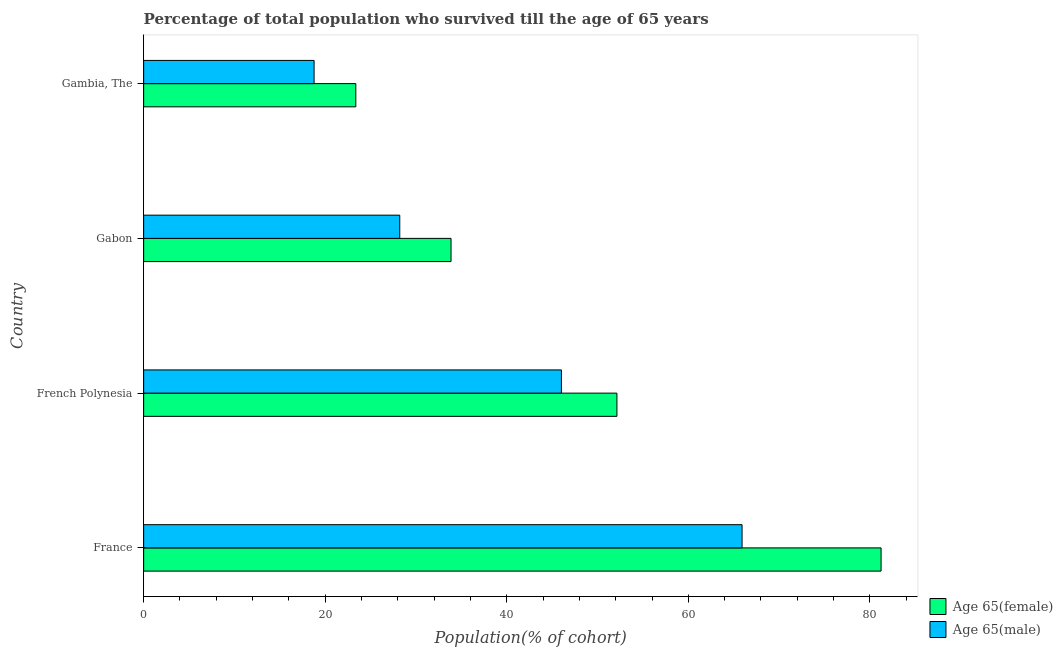How many different coloured bars are there?
Your response must be concise. 2. How many groups of bars are there?
Offer a very short reply. 4. How many bars are there on the 4th tick from the bottom?
Your answer should be compact. 2. What is the percentage of female population who survived till age of 65 in France?
Your answer should be compact. 81.23. Across all countries, what is the maximum percentage of male population who survived till age of 65?
Offer a very short reply. 65.92. Across all countries, what is the minimum percentage of female population who survived till age of 65?
Your answer should be compact. 23.37. In which country was the percentage of male population who survived till age of 65 minimum?
Provide a succinct answer. Gambia, The. What is the total percentage of female population who survived till age of 65 in the graph?
Provide a short and direct response. 190.6. What is the difference between the percentage of male population who survived till age of 65 in French Polynesia and that in Gambia, The?
Provide a short and direct response. 27.25. What is the difference between the percentage of male population who survived till age of 65 in Gambia, The and the percentage of female population who survived till age of 65 in France?
Offer a terse response. -62.46. What is the average percentage of male population who survived till age of 65 per country?
Ensure brevity in your answer.  39.73. What is the difference between the percentage of female population who survived till age of 65 and percentage of male population who survived till age of 65 in Gabon?
Your response must be concise. 5.65. In how many countries, is the percentage of female population who survived till age of 65 greater than 80 %?
Offer a terse response. 1. What is the ratio of the percentage of male population who survived till age of 65 in Gabon to that in Gambia, The?
Ensure brevity in your answer.  1.5. Is the percentage of female population who survived till age of 65 in France less than that in French Polynesia?
Offer a very short reply. No. What is the difference between the highest and the second highest percentage of male population who survived till age of 65?
Give a very brief answer. 19.9. What is the difference between the highest and the lowest percentage of female population who survived till age of 65?
Offer a terse response. 57.86. Is the sum of the percentage of female population who survived till age of 65 in France and Gambia, The greater than the maximum percentage of male population who survived till age of 65 across all countries?
Provide a succinct answer. Yes. What does the 2nd bar from the top in Gambia, The represents?
Give a very brief answer. Age 65(female). What does the 2nd bar from the bottom in French Polynesia represents?
Ensure brevity in your answer.  Age 65(male). How many bars are there?
Ensure brevity in your answer.  8. How many countries are there in the graph?
Offer a terse response. 4. Are the values on the major ticks of X-axis written in scientific E-notation?
Offer a terse response. No. Does the graph contain grids?
Your answer should be compact. No. How are the legend labels stacked?
Your answer should be very brief. Vertical. What is the title of the graph?
Your response must be concise. Percentage of total population who survived till the age of 65 years. What is the label or title of the X-axis?
Your answer should be very brief. Population(% of cohort). What is the Population(% of cohort) of Age 65(female) in France?
Keep it short and to the point. 81.23. What is the Population(% of cohort) in Age 65(male) in France?
Offer a very short reply. 65.92. What is the Population(% of cohort) in Age 65(female) in French Polynesia?
Provide a short and direct response. 52.14. What is the Population(% of cohort) in Age 65(male) in French Polynesia?
Your response must be concise. 46.02. What is the Population(% of cohort) of Age 65(female) in Gabon?
Your answer should be very brief. 33.86. What is the Population(% of cohort) of Age 65(male) in Gabon?
Offer a very short reply. 28.21. What is the Population(% of cohort) in Age 65(female) in Gambia, The?
Your response must be concise. 23.37. What is the Population(% of cohort) of Age 65(male) in Gambia, The?
Provide a succinct answer. 18.78. Across all countries, what is the maximum Population(% of cohort) of Age 65(female)?
Offer a terse response. 81.23. Across all countries, what is the maximum Population(% of cohort) of Age 65(male)?
Provide a short and direct response. 65.92. Across all countries, what is the minimum Population(% of cohort) in Age 65(female)?
Give a very brief answer. 23.37. Across all countries, what is the minimum Population(% of cohort) of Age 65(male)?
Give a very brief answer. 18.78. What is the total Population(% of cohort) in Age 65(female) in the graph?
Your answer should be very brief. 190.6. What is the total Population(% of cohort) of Age 65(male) in the graph?
Your response must be concise. 158.93. What is the difference between the Population(% of cohort) of Age 65(female) in France and that in French Polynesia?
Offer a terse response. 29.1. What is the difference between the Population(% of cohort) in Age 65(male) in France and that in French Polynesia?
Make the answer very short. 19.9. What is the difference between the Population(% of cohort) in Age 65(female) in France and that in Gabon?
Your answer should be compact. 47.37. What is the difference between the Population(% of cohort) in Age 65(male) in France and that in Gabon?
Give a very brief answer. 37.71. What is the difference between the Population(% of cohort) in Age 65(female) in France and that in Gambia, The?
Ensure brevity in your answer.  57.86. What is the difference between the Population(% of cohort) in Age 65(male) in France and that in Gambia, The?
Offer a terse response. 47.15. What is the difference between the Population(% of cohort) in Age 65(female) in French Polynesia and that in Gabon?
Provide a succinct answer. 18.27. What is the difference between the Population(% of cohort) in Age 65(male) in French Polynesia and that in Gabon?
Keep it short and to the point. 17.81. What is the difference between the Population(% of cohort) in Age 65(female) in French Polynesia and that in Gambia, The?
Your answer should be very brief. 28.76. What is the difference between the Population(% of cohort) in Age 65(male) in French Polynesia and that in Gambia, The?
Ensure brevity in your answer.  27.25. What is the difference between the Population(% of cohort) in Age 65(female) in Gabon and that in Gambia, The?
Your answer should be very brief. 10.49. What is the difference between the Population(% of cohort) of Age 65(male) in Gabon and that in Gambia, The?
Your answer should be compact. 9.44. What is the difference between the Population(% of cohort) in Age 65(female) in France and the Population(% of cohort) in Age 65(male) in French Polynesia?
Offer a very short reply. 35.21. What is the difference between the Population(% of cohort) of Age 65(female) in France and the Population(% of cohort) of Age 65(male) in Gabon?
Keep it short and to the point. 53.02. What is the difference between the Population(% of cohort) of Age 65(female) in France and the Population(% of cohort) of Age 65(male) in Gambia, The?
Your answer should be compact. 62.46. What is the difference between the Population(% of cohort) of Age 65(female) in French Polynesia and the Population(% of cohort) of Age 65(male) in Gabon?
Ensure brevity in your answer.  23.92. What is the difference between the Population(% of cohort) in Age 65(female) in French Polynesia and the Population(% of cohort) in Age 65(male) in Gambia, The?
Provide a succinct answer. 33.36. What is the difference between the Population(% of cohort) of Age 65(female) in Gabon and the Population(% of cohort) of Age 65(male) in Gambia, The?
Give a very brief answer. 15.09. What is the average Population(% of cohort) in Age 65(female) per country?
Provide a succinct answer. 47.65. What is the average Population(% of cohort) in Age 65(male) per country?
Offer a very short reply. 39.73. What is the difference between the Population(% of cohort) in Age 65(female) and Population(% of cohort) in Age 65(male) in France?
Keep it short and to the point. 15.31. What is the difference between the Population(% of cohort) of Age 65(female) and Population(% of cohort) of Age 65(male) in French Polynesia?
Provide a succinct answer. 6.11. What is the difference between the Population(% of cohort) of Age 65(female) and Population(% of cohort) of Age 65(male) in Gabon?
Your response must be concise. 5.65. What is the difference between the Population(% of cohort) of Age 65(female) and Population(% of cohort) of Age 65(male) in Gambia, The?
Provide a short and direct response. 4.6. What is the ratio of the Population(% of cohort) of Age 65(female) in France to that in French Polynesia?
Your answer should be very brief. 1.56. What is the ratio of the Population(% of cohort) in Age 65(male) in France to that in French Polynesia?
Keep it short and to the point. 1.43. What is the ratio of the Population(% of cohort) in Age 65(female) in France to that in Gabon?
Your answer should be compact. 2.4. What is the ratio of the Population(% of cohort) in Age 65(male) in France to that in Gabon?
Your answer should be compact. 2.34. What is the ratio of the Population(% of cohort) of Age 65(female) in France to that in Gambia, The?
Provide a succinct answer. 3.48. What is the ratio of the Population(% of cohort) in Age 65(male) in France to that in Gambia, The?
Your response must be concise. 3.51. What is the ratio of the Population(% of cohort) of Age 65(female) in French Polynesia to that in Gabon?
Offer a terse response. 1.54. What is the ratio of the Population(% of cohort) of Age 65(male) in French Polynesia to that in Gabon?
Keep it short and to the point. 1.63. What is the ratio of the Population(% of cohort) of Age 65(female) in French Polynesia to that in Gambia, The?
Provide a succinct answer. 2.23. What is the ratio of the Population(% of cohort) of Age 65(male) in French Polynesia to that in Gambia, The?
Offer a terse response. 2.45. What is the ratio of the Population(% of cohort) of Age 65(female) in Gabon to that in Gambia, The?
Ensure brevity in your answer.  1.45. What is the ratio of the Population(% of cohort) in Age 65(male) in Gabon to that in Gambia, The?
Give a very brief answer. 1.5. What is the difference between the highest and the second highest Population(% of cohort) in Age 65(female)?
Keep it short and to the point. 29.1. What is the difference between the highest and the second highest Population(% of cohort) in Age 65(male)?
Your answer should be compact. 19.9. What is the difference between the highest and the lowest Population(% of cohort) of Age 65(female)?
Offer a very short reply. 57.86. What is the difference between the highest and the lowest Population(% of cohort) in Age 65(male)?
Keep it short and to the point. 47.15. 